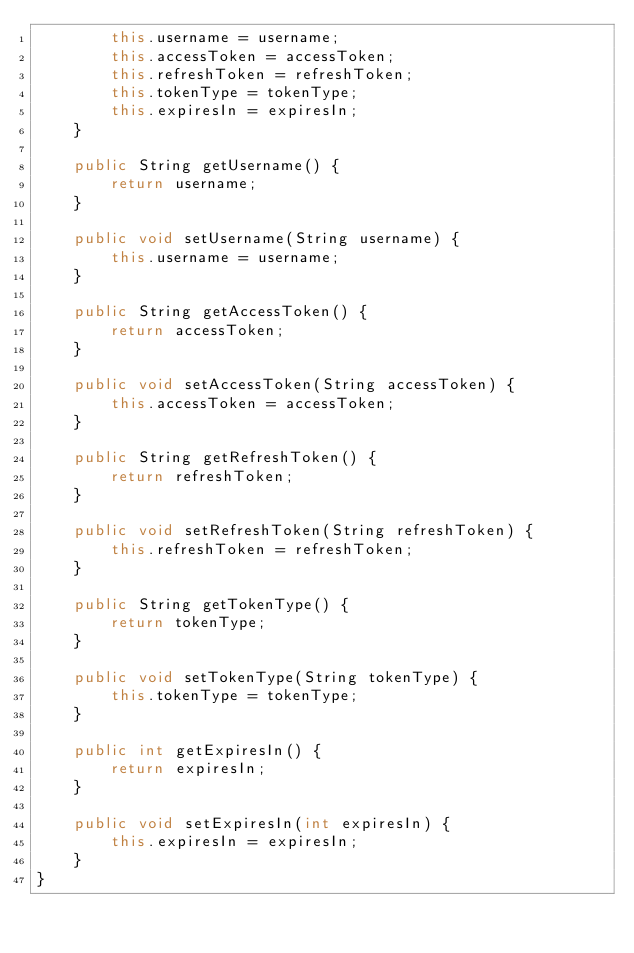<code> <loc_0><loc_0><loc_500><loc_500><_Java_>        this.username = username;
        this.accessToken = accessToken;
        this.refreshToken = refreshToken;
        this.tokenType = tokenType;
        this.expiresIn = expiresIn;
    }

    public String getUsername() {
        return username;
    }

    public void setUsername(String username) {
        this.username = username;
    }

    public String getAccessToken() {
        return accessToken;
    }

    public void setAccessToken(String accessToken) {
        this.accessToken = accessToken;
    }

    public String getRefreshToken() {
        return refreshToken;
    }

    public void setRefreshToken(String refreshToken) {
        this.refreshToken = refreshToken;
    }

    public String getTokenType() {
        return tokenType;
    }

    public void setTokenType(String tokenType) {
        this.tokenType = tokenType;
    }

    public int getExpiresIn() {
        return expiresIn;
    }

    public void setExpiresIn(int expiresIn) {
        this.expiresIn = expiresIn;
    }
}
</code> 